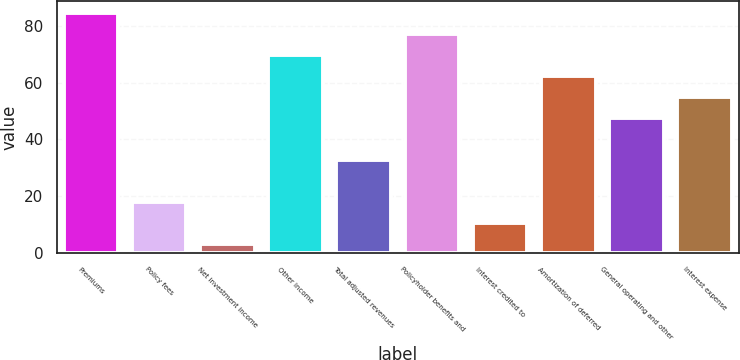Convert chart to OTSL. <chart><loc_0><loc_0><loc_500><loc_500><bar_chart><fcel>Premiums<fcel>Policy fees<fcel>Net investment income<fcel>Other income<fcel>Total adjusted revenues<fcel>Policyholder benefits and<fcel>Interest credited to<fcel>Amortization of deferred<fcel>General operating and other<fcel>Interest expense<nl><fcel>84.4<fcel>17.8<fcel>3<fcel>69.6<fcel>32.6<fcel>77<fcel>10.4<fcel>62.2<fcel>47.4<fcel>54.8<nl></chart> 